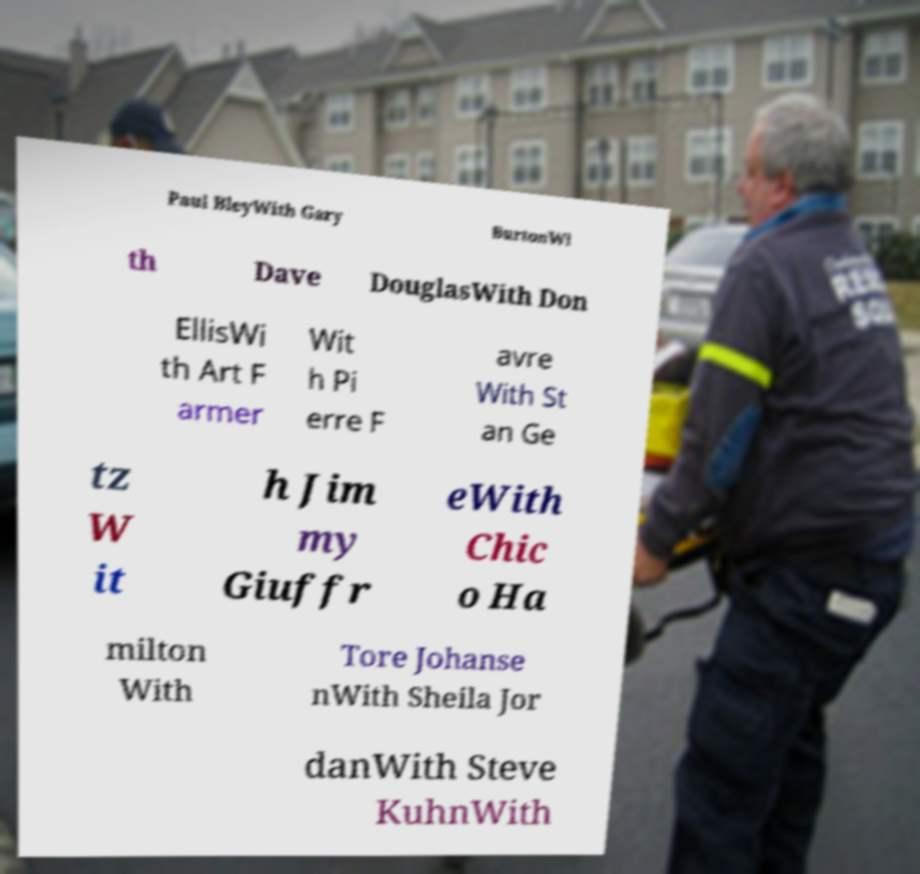Please read and relay the text visible in this image. What does it say? Paul BleyWith Gary BurtonWi th Dave DouglasWith Don EllisWi th Art F armer Wit h Pi erre F avre With St an Ge tz W it h Jim my Giuffr eWith Chic o Ha milton With Tore Johanse nWith Sheila Jor danWith Steve KuhnWith 